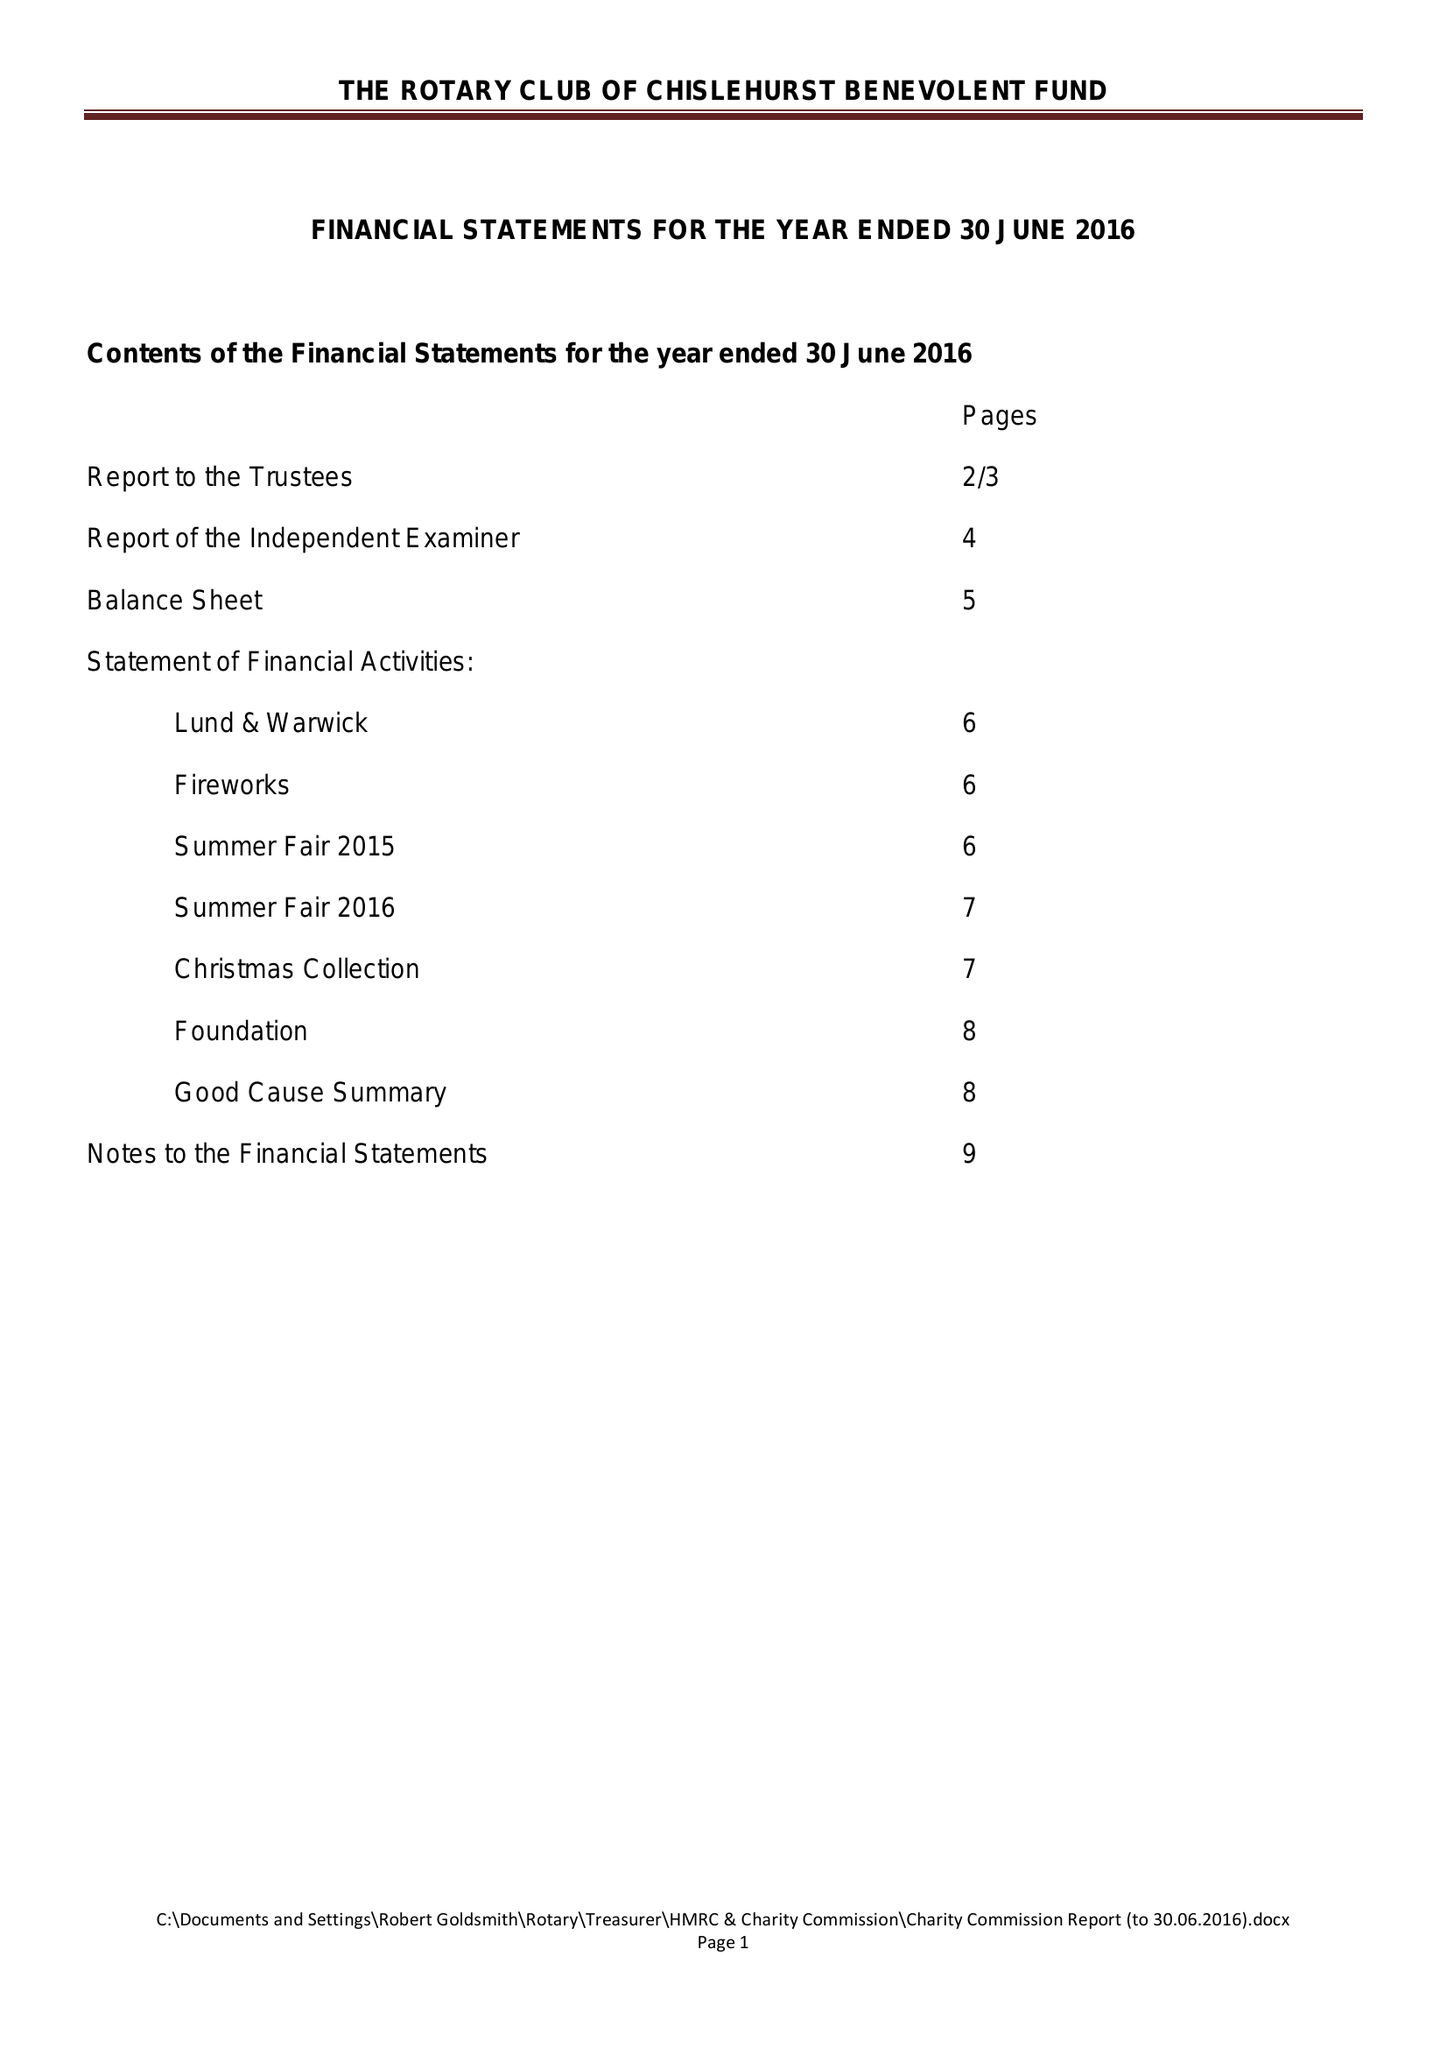What is the value for the income_annually_in_british_pounds?
Answer the question using a single word or phrase. 30406.00 